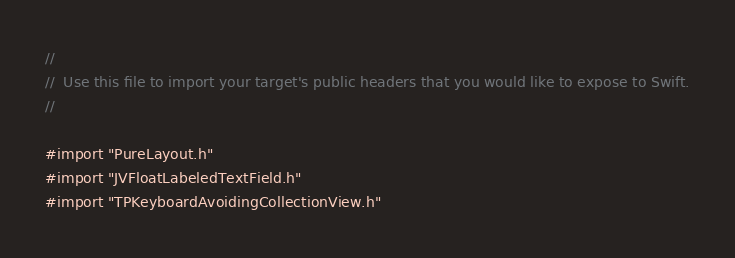Convert code to text. <code><loc_0><loc_0><loc_500><loc_500><_C_>//
//  Use this file to import your target's public headers that you would like to expose to Swift.
//

#import "PureLayout.h"
#import "JVFloatLabeledTextField.h"
#import "TPKeyboardAvoidingCollectionView.h"
</code> 